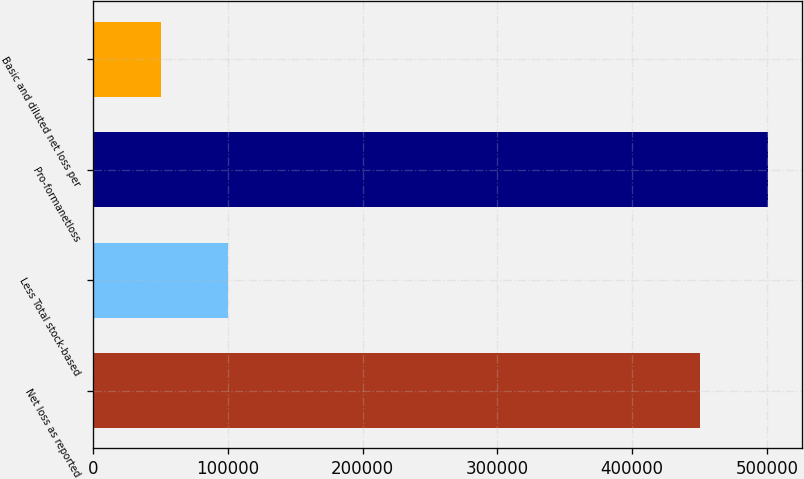<chart> <loc_0><loc_0><loc_500><loc_500><bar_chart><fcel>Net loss as reported<fcel>Less Total stock-based<fcel>Pro-formanetloss<fcel>Basic and diluted net loss per<nl><fcel>450094<fcel>100129<fcel>500634<fcel>50065.5<nl></chart> 